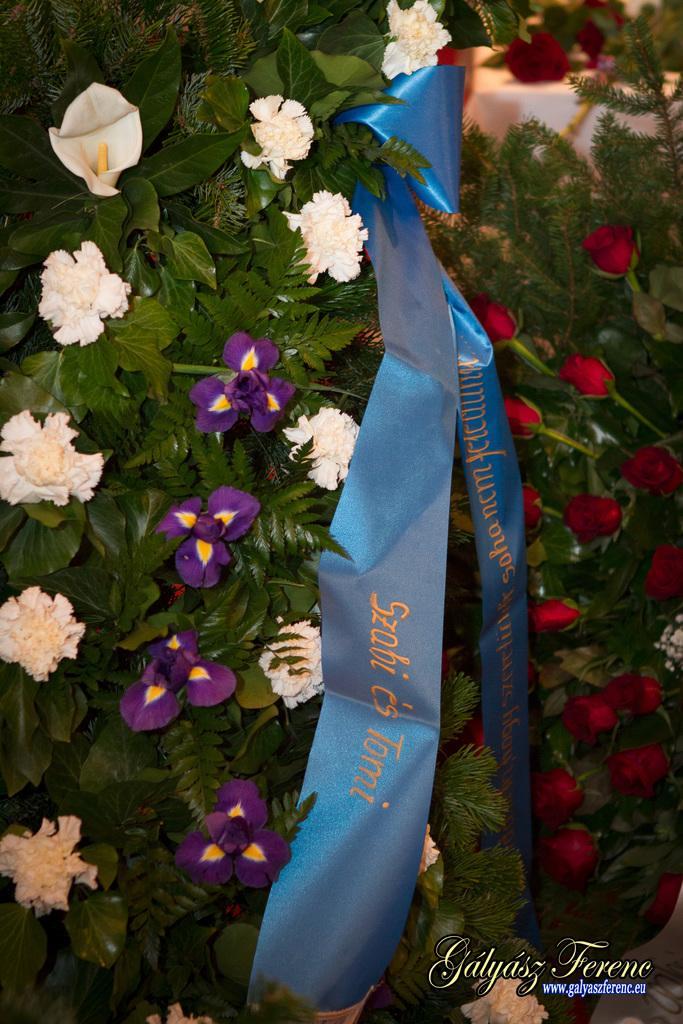Could you give a brief overview of what you see in this image? In this image we can see few plants. There are many flowers to the plants. There is an object in the image. There is some text at the bottom of the image. 